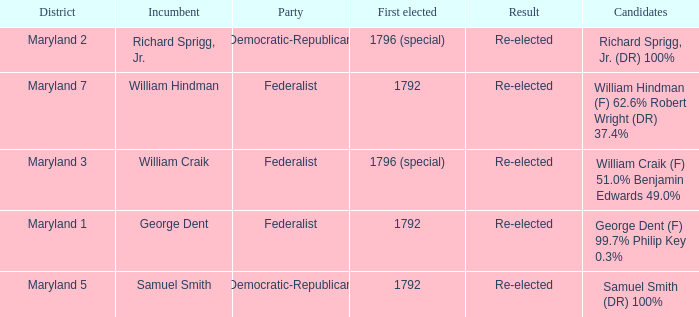What is the party when the incumbent is samuel smith? Democratic-Republican. 